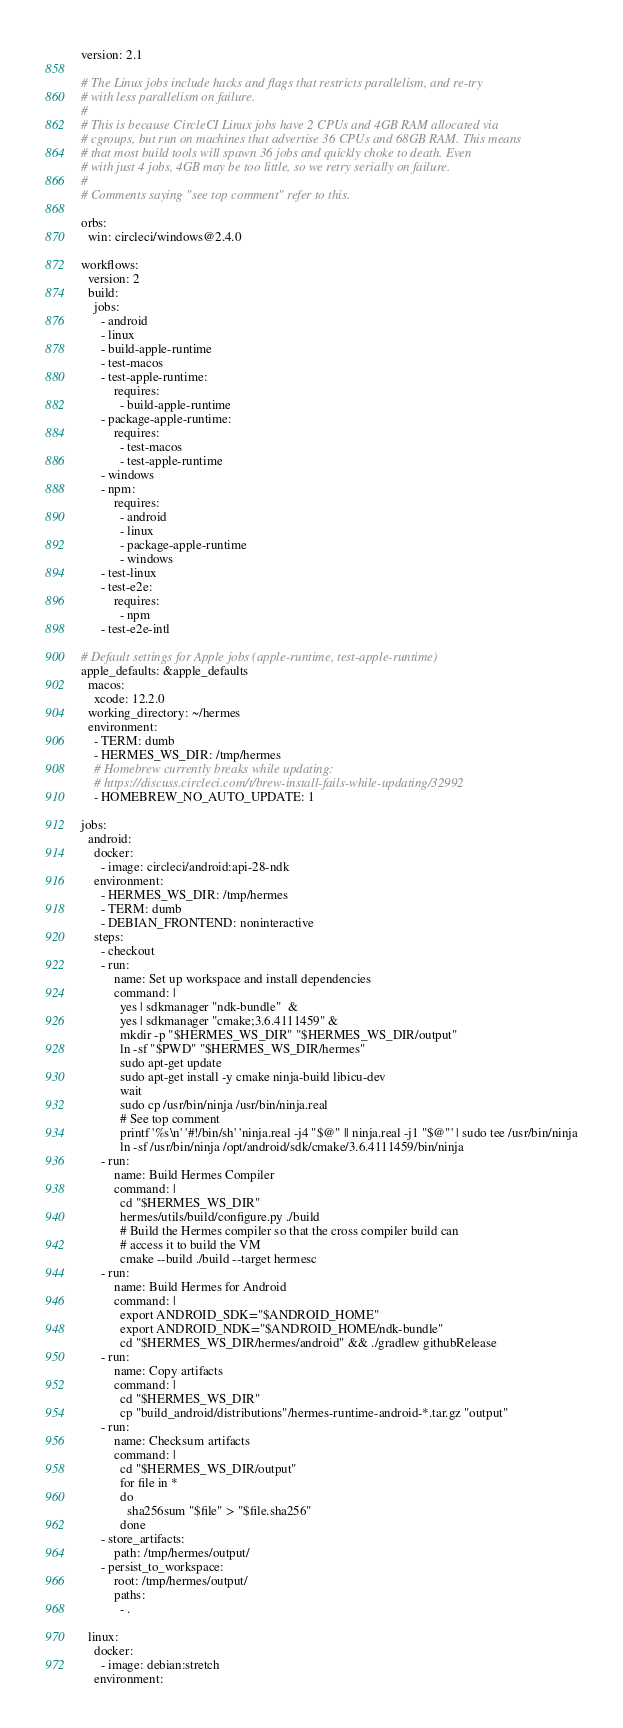<code> <loc_0><loc_0><loc_500><loc_500><_YAML_>version: 2.1

# The Linux jobs include hacks and flags that restricts parallelism, and re-try
# with less parallelism on failure.
#
# This is because CircleCI Linux jobs have 2 CPUs and 4GB RAM allocated via
# cgroups, but run on machines that advertise 36 CPUs and 68GB RAM. This means
# that most build tools will spawn 36 jobs and quickly choke to death. Even
# with just 4 jobs, 4GB may be too little, so we retry serially on failure.
#
# Comments saying "see top comment" refer to this.

orbs:
  win: circleci/windows@2.4.0

workflows:
  version: 2
  build:
    jobs:
      - android
      - linux
      - build-apple-runtime
      - test-macos
      - test-apple-runtime:
          requires:
            - build-apple-runtime
      - package-apple-runtime:
          requires:
            - test-macos
            - test-apple-runtime
      - windows
      - npm:
          requires:
            - android
            - linux
            - package-apple-runtime
            - windows
      - test-linux
      - test-e2e:
          requires:
            - npm
      - test-e2e-intl

# Default settings for Apple jobs (apple-runtime, test-apple-runtime)
apple_defaults: &apple_defaults
  macos:
    xcode: 12.2.0
  working_directory: ~/hermes
  environment:
    - TERM: dumb
    - HERMES_WS_DIR: /tmp/hermes
    # Homebrew currently breaks while updating:
    # https://discuss.circleci.com/t/brew-install-fails-while-updating/32992
    - HOMEBREW_NO_AUTO_UPDATE: 1

jobs:
  android:
    docker:
      - image: circleci/android:api-28-ndk
    environment:
      - HERMES_WS_DIR: /tmp/hermes
      - TERM: dumb
      - DEBIAN_FRONTEND: noninteractive
    steps:
      - checkout
      - run:
          name: Set up workspace and install dependencies
          command: |
            yes | sdkmanager "ndk-bundle"  &
            yes | sdkmanager "cmake;3.6.4111459" &
            mkdir -p "$HERMES_WS_DIR" "$HERMES_WS_DIR/output"
            ln -sf "$PWD" "$HERMES_WS_DIR/hermes"
            sudo apt-get update
            sudo apt-get install -y cmake ninja-build libicu-dev
            wait
            sudo cp /usr/bin/ninja /usr/bin/ninja.real
            # See top comment
            printf '%s\n' '#!/bin/sh' 'ninja.real -j4 "$@" || ninja.real -j1 "$@"' | sudo tee /usr/bin/ninja
            ln -sf /usr/bin/ninja /opt/android/sdk/cmake/3.6.4111459/bin/ninja
      - run:
          name: Build Hermes Compiler
          command: |
            cd "$HERMES_WS_DIR"
            hermes/utils/build/configure.py ./build
            # Build the Hermes compiler so that the cross compiler build can
            # access it to build the VM
            cmake --build ./build --target hermesc
      - run:
          name: Build Hermes for Android
          command: |
            export ANDROID_SDK="$ANDROID_HOME"
            export ANDROID_NDK="$ANDROID_HOME/ndk-bundle"
            cd "$HERMES_WS_DIR/hermes/android" && ./gradlew githubRelease
      - run:
          name: Copy artifacts
          command: |
            cd "$HERMES_WS_DIR"
            cp "build_android/distributions"/hermes-runtime-android-*.tar.gz "output"
      - run:
          name: Checksum artifacts
          command: |
            cd "$HERMES_WS_DIR/output"
            for file in *
            do
              sha256sum "$file" > "$file.sha256"
            done
      - store_artifacts:
          path: /tmp/hermes/output/
      - persist_to_workspace:
          root: /tmp/hermes/output/
          paths:
            - .

  linux:
    docker:
      - image: debian:stretch
    environment:</code> 